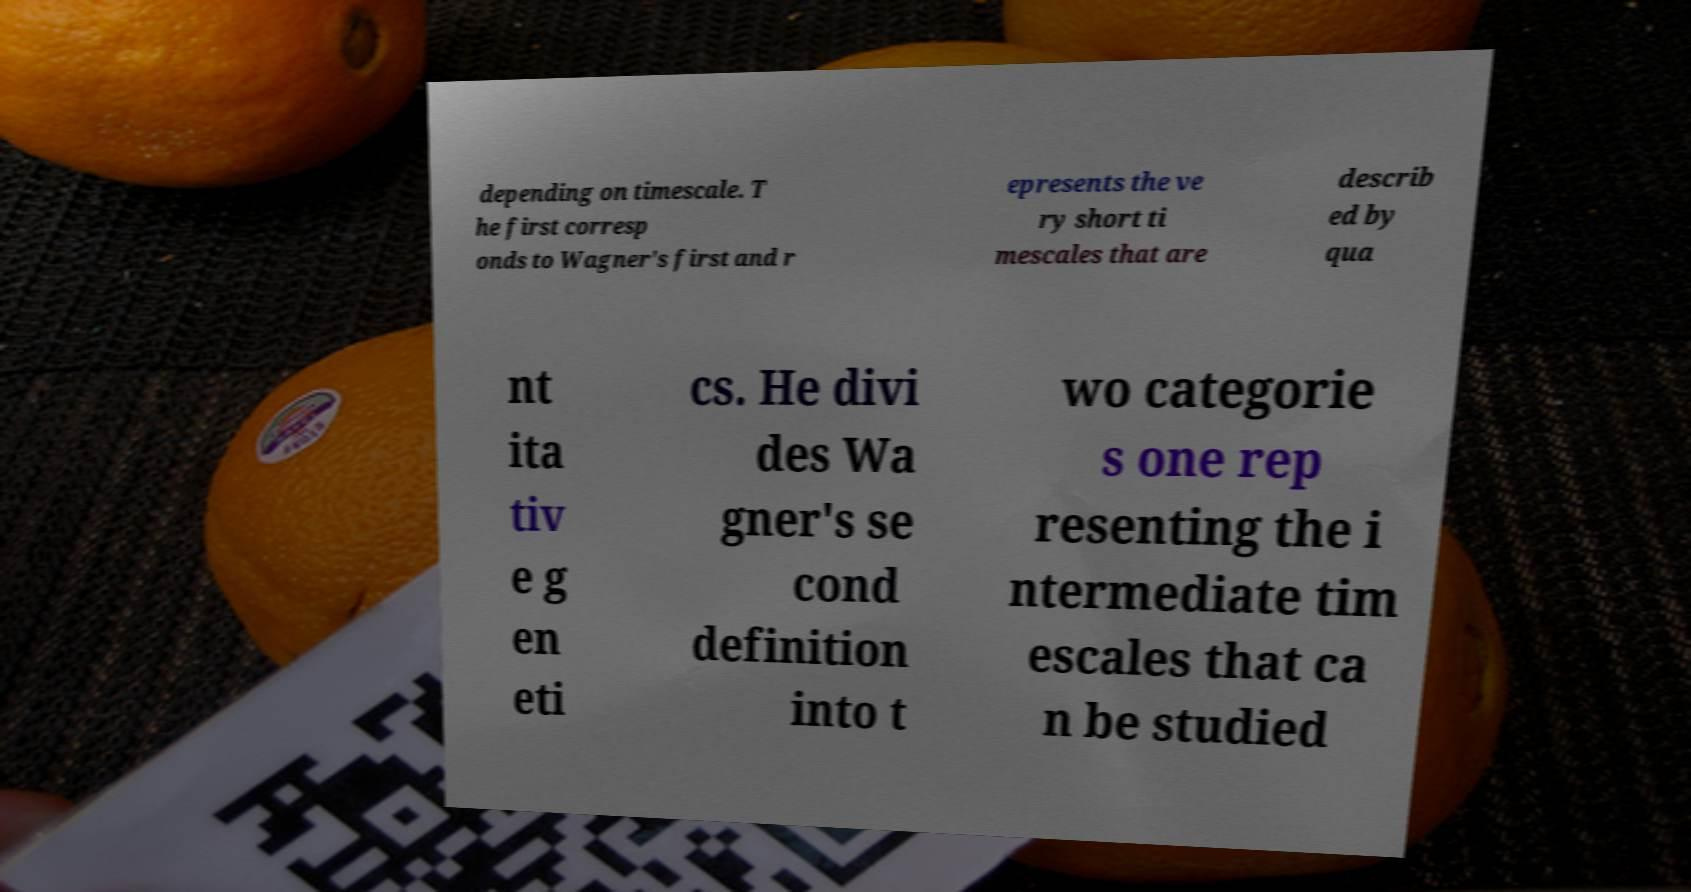Could you assist in decoding the text presented in this image and type it out clearly? depending on timescale. T he first corresp onds to Wagner's first and r epresents the ve ry short ti mescales that are describ ed by qua nt ita tiv e g en eti cs. He divi des Wa gner's se cond definition into t wo categorie s one rep resenting the i ntermediate tim escales that ca n be studied 